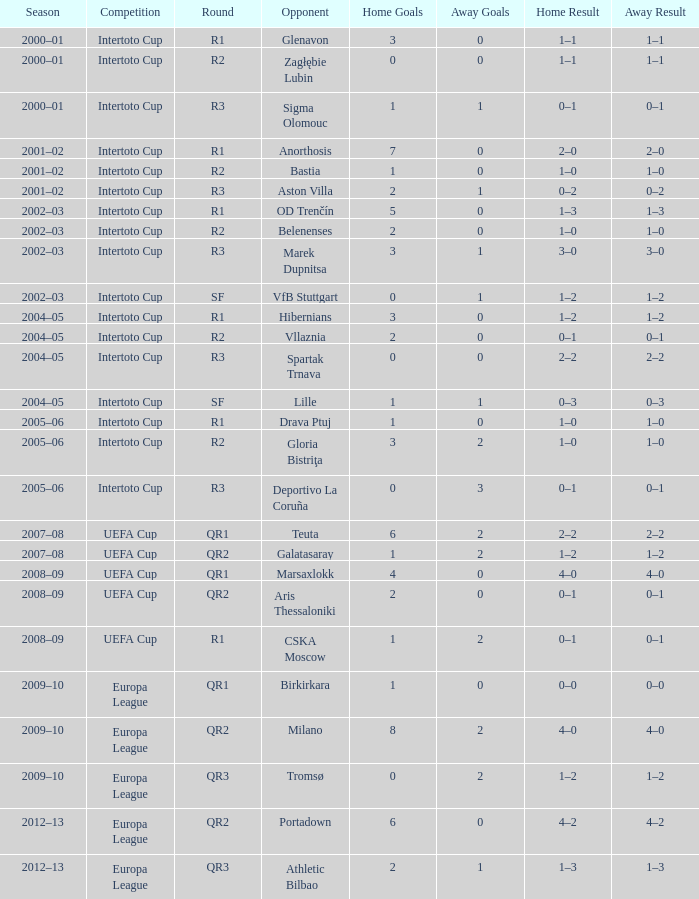What is the home score with marek dupnitsa as opponent? 3–1. 